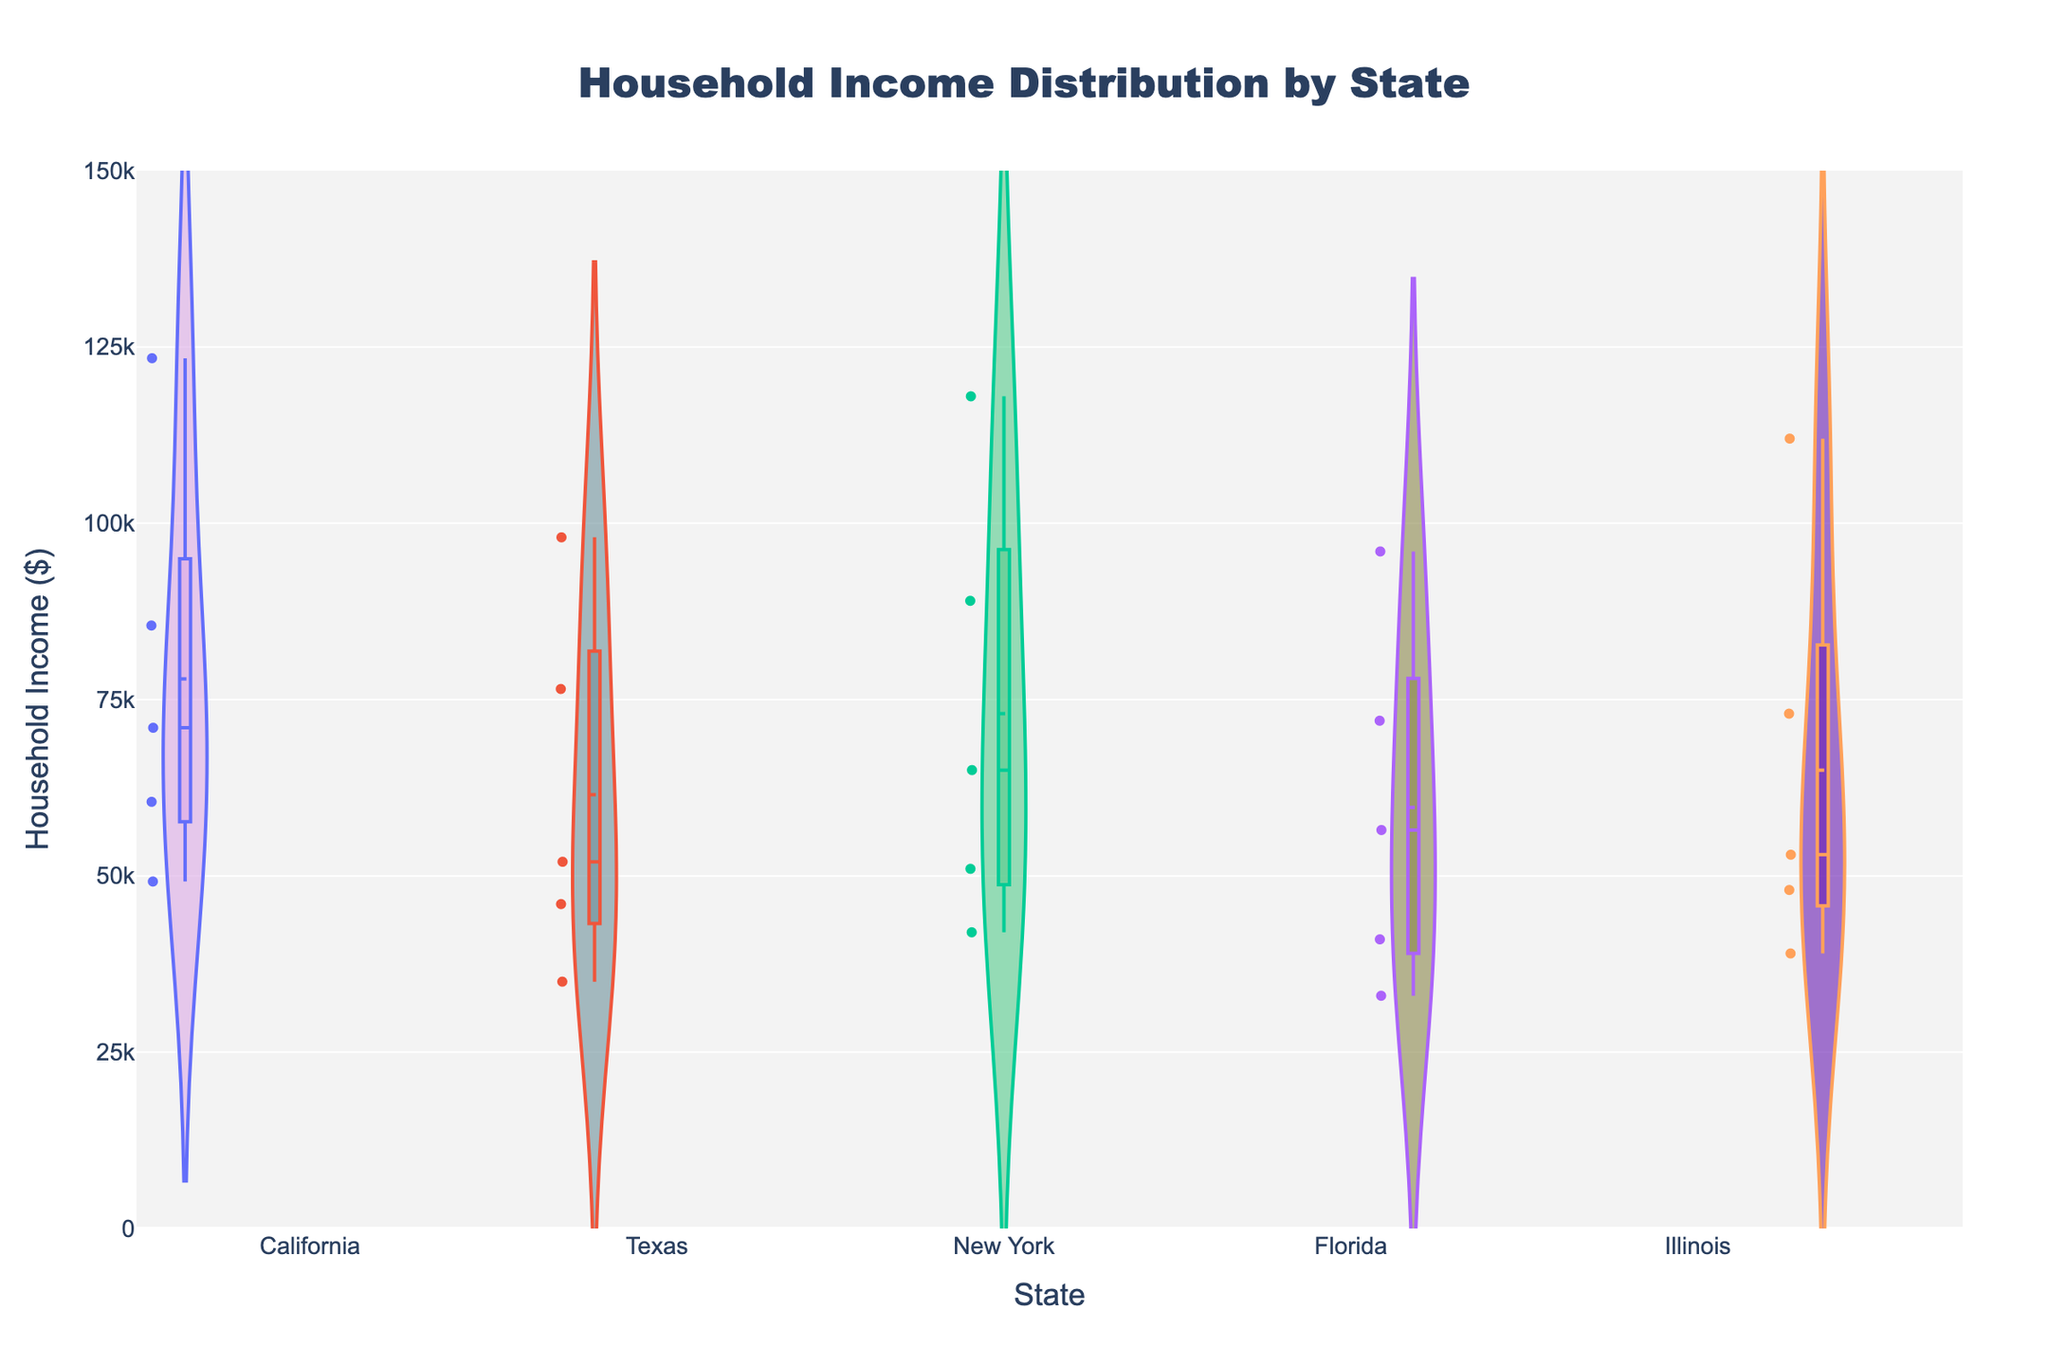what's the title of the figure? The title of the figure is usually prominently displayed at the top. In this case, it says 'Household Income Distribution by State'.
Answer: Household Income Distribution by State what is the range of the y-axis in the figure? The y-axis range can be determined by looking at the label and ticks along the axis. Here, it ranges from $0 to $150,000.
Answer: $0 to $150,000 which state has the highest median household income? The median income is indicated by the central line in each state's box plot. California has the highest median line that appears roughly around $71,000.
Answer: California how many household income data points are there for Florida? In a violin plot with points visible, each dot represents a data point. Counting them for Florida, there are 5 data points.
Answer: 5 what's the mean household income for Illinois? The mean income is indicated by the mean line in each violin plot. For Illinois, the mean line is roughly at $65,000.
Answer: Approximately $65,000 which state has the widest range of household incomes? The range is the difference between the highest and lowest points in the violin plot. California has the widest range from about $49,000 to $123,400.
Answer: California compare the household income distributions of Texas and New York. Which state has higher variability? Variability in a violin plot can be observed by looking at the width and spread of the data. Texas has a narrower distribution compared to New York which indicates lower variability.
Answer: New York which states have household incomes above $100,000? The violin plots that extend above the $100,000 mark are California, New York, and Illinois.
Answer: California, New York, Illinois what is the mean difference in household income between Texas and Florida? Identify the mean lines for both states. For Texas, it's approximately $65,000, and for Florida, it's around $60,000. The difference is $65,000 - $60,000 = $5,000.
Answer: $5,000 